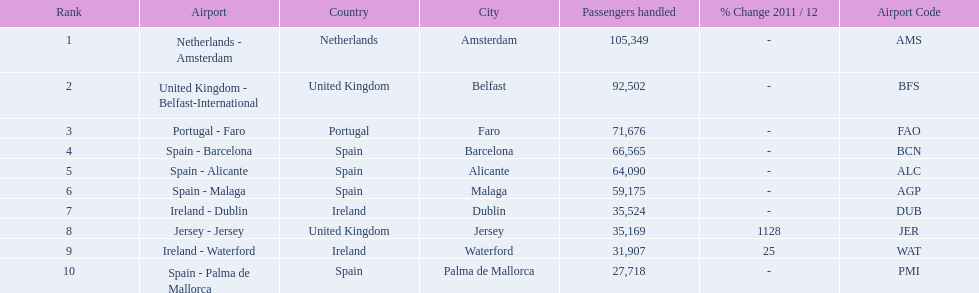How many passengers did the united kingdom handle? 92,502. Who handled more passengers than this? Netherlands - Amsterdam. 